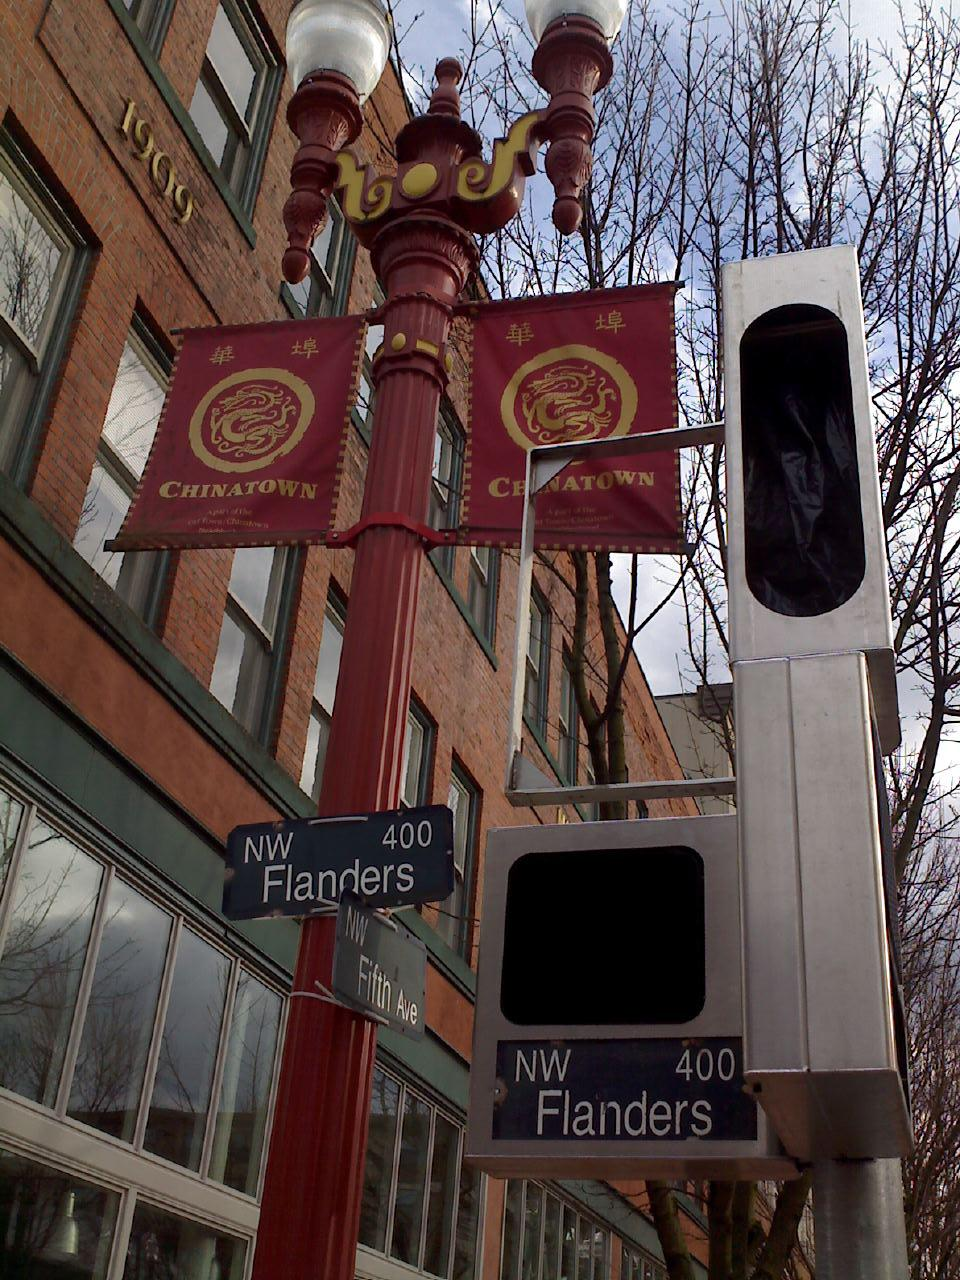Question: when in a day is it?
Choices:
A. Lunchtime.
B. Dawn.
C. Dusk.
D. Daytime.
Answer with the letter. Answer: D Question: what is the street name?
Choices:
A. Nw 400 flanders.
B. Main Street.
C. Old Brook Road.
D. Pinehaven Drive.
Answer with the letter. Answer: A Question: how many lights are there?
Choices:
A. 3.
B. 1.
C. 2.
D. 6.
Answer with the letter. Answer: C Question: what is the building color?
Choices:
A. Grey.
B. Red.
C. Brown.
D. Tan.
Answer with the letter. Answer: C Question: what is the building made of?
Choices:
A. Bricks.
B. Woods.
C. Concrete.
D. Stone.
Answer with the letter. Answer: A Question: what is red and yellow?
Choices:
A. Peppers.
B. Mangoes.
C. Buses.
D. The street lamp.
Answer with the letter. Answer: D Question: where was the picture taken?
Choices:
A. At fifth and flanders.
B. At a studio.
C. In front of the Whitehouse.
D. On the bridge.
Answer with the letter. Answer: A Question: what has two lights?
Choices:
A. Car lights.
B. Neon signs.
C. The billboards.
D. The street light.
Answer with the letter. Answer: D Question: what is unlit?
Choices:
A. The street.
B. The sidewalk.
C. Patio.
D. The crosswalk.
Answer with the letter. Answer: D Question: what is strapped to poles?
Choices:
A. Advertisements.
B. The street signs.
C. Warning signs.
D. Name plates.
Answer with the letter. Answer: B Question: what is the building made of?
Choices:
A. Concrete.
B. Brick.
C. Aluminum siding.
D. Sod.
Answer with the letter. Answer: B Question: what does the black sign say?
Choices:
A. Target.
B. 100 e.
C. Lincoln.
D. Nw 400 flanders.
Answer with the letter. Answer: D Question: what part of town is this?
Choices:
A. South east.
B. Campus area.
C. North west part.
D. Industrial area.
Answer with the letter. Answer: C Question: how many red and gold flags are there?
Choices:
A. Three.
B. Four.
C. Two.
D. Five.
Answer with the letter. Answer: C Question: where is the small light pole?
Choices:
A. At the center of State and Main.
B. In front of the condominiums.
C. On the north side of the park.
D. On the side of the road in chinatown.
Answer with the letter. Answer: D 